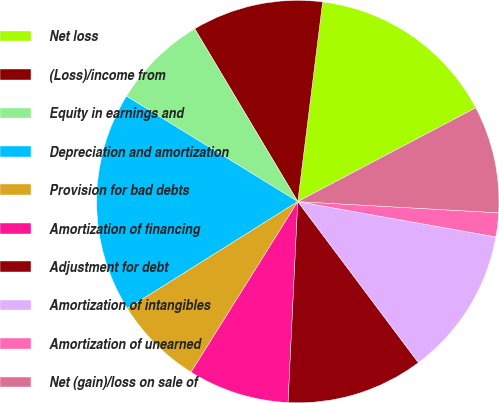Convert chart. <chart><loc_0><loc_0><loc_500><loc_500><pie_chart><fcel>Net loss<fcel>(Loss)/income from<fcel>Equity in earnings and<fcel>Depreciation and amortization<fcel>Provision for bad debts<fcel>Amortization of financing<fcel>Adjustment for debt<fcel>Amortization of intangibles<fcel>Amortization of unearned<fcel>Net (gain)/loss on sale of<nl><fcel>15.31%<fcel>10.53%<fcel>7.66%<fcel>17.7%<fcel>7.18%<fcel>8.13%<fcel>11.0%<fcel>11.96%<fcel>1.92%<fcel>8.61%<nl></chart> 